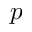Convert formula to latex. <formula><loc_0><loc_0><loc_500><loc_500>p</formula> 